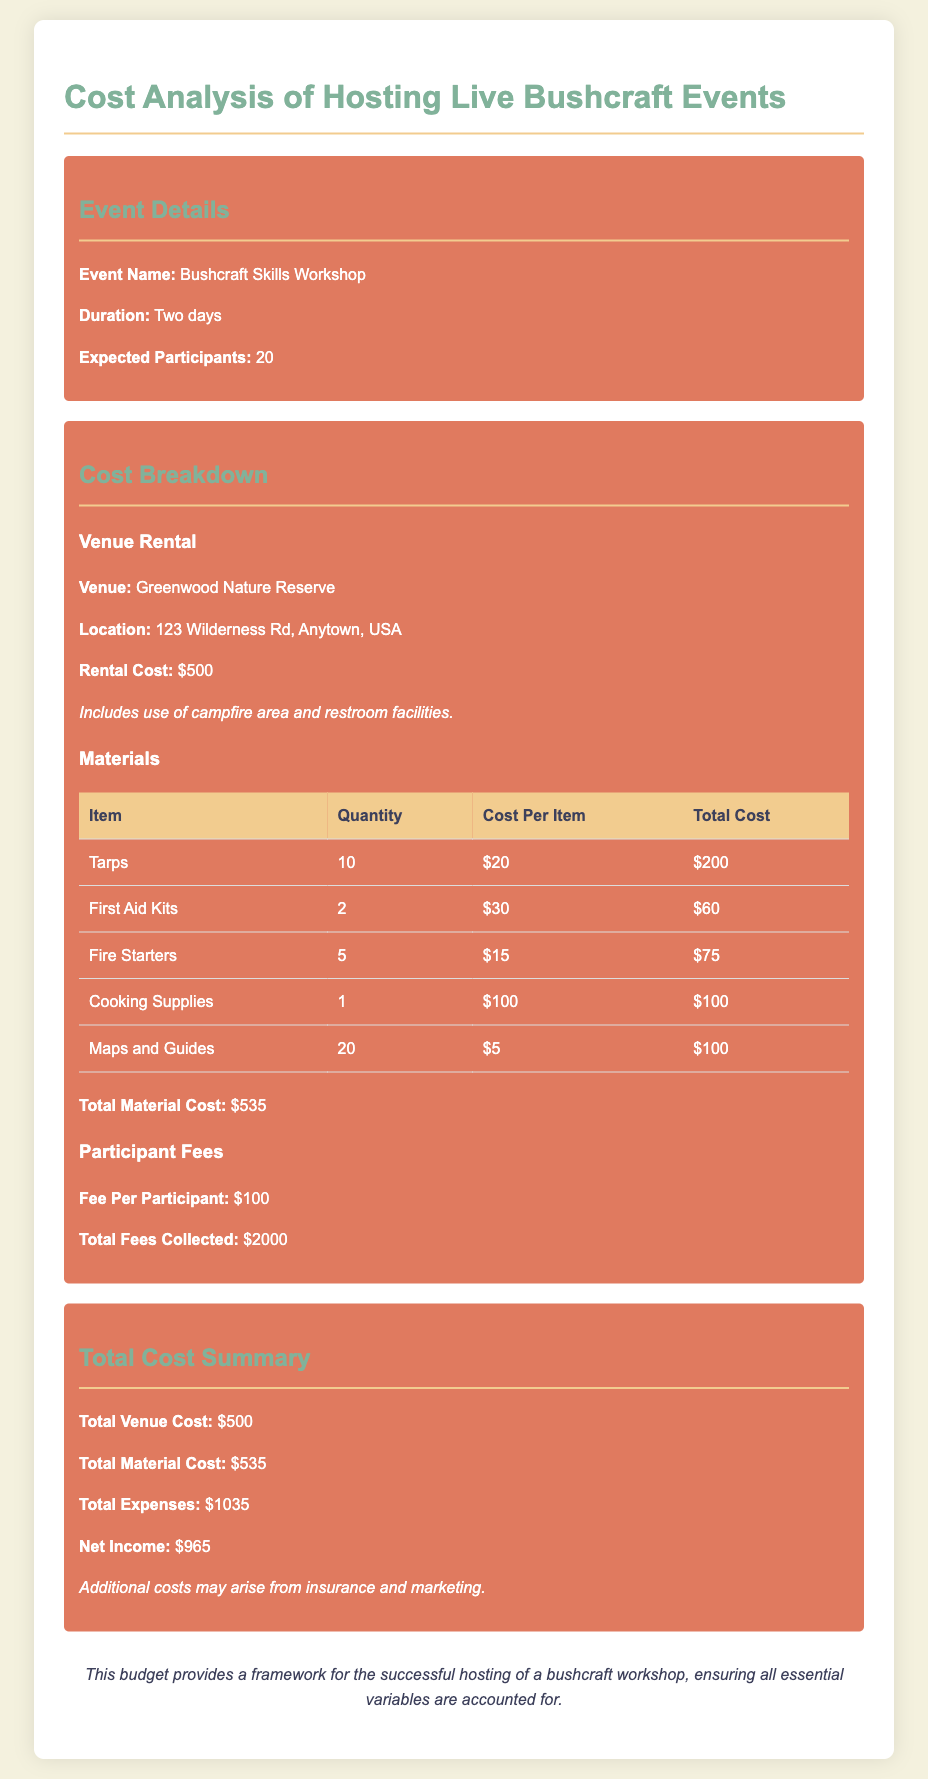What is the event name? The event name is provided in the document under event details.
Answer: Bushcraft Skills Workshop What is the venue rental cost? The venue rental cost is listed under the cost breakdown section.
Answer: $500 How many participants are expected? The expected participants count is mentioned in the event details section.
Answer: 20 What is the total material cost? The total material cost is summarized at the end of the cost breakdown section.
Answer: $535 What is the fee per participant? The fee per participant is indicated under the participant fees section.
Answer: $100 What is the net income from the event? The net income is calculated based on total income and total expenses in the total cost summary.
Answer: $965 What materials are included in the budget? The materials are listed in a table format in the cost breakdown section.
Answer: Tarps, First Aid Kits, Fire Starters, Cooking Supplies, Maps and Guides How long is the event duration? The event duration is specified in the event details section.
Answer: Two days What additional costs may arise? Possible additional costs are mentioned in the total summary and referred to generally.
Answer: Insurance and marketing 